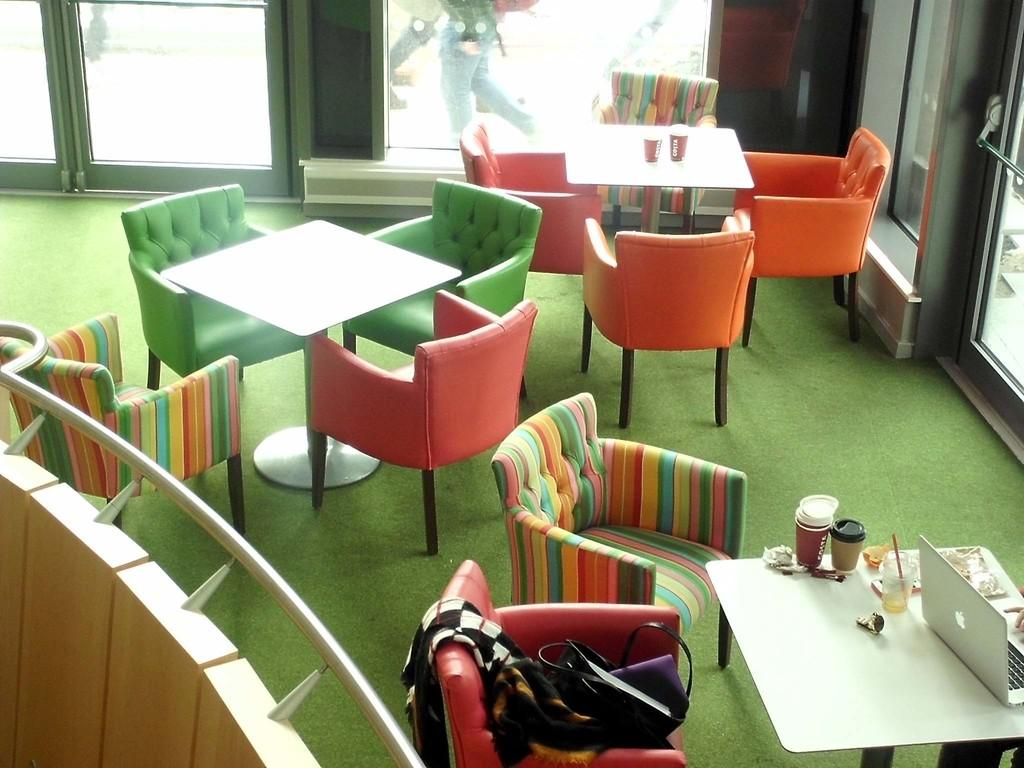What type of furniture is present in the room? There are chairs and tables in the room. What might be used for sitting or placing items in the room? Chairs and tables are present in the room for sitting and placing items. What can be seen in the background of the image? There is a door visible in the background, and people's legs are also visible. What might be used for entering or exiting the room? The door visible in the background might be used for entering or exiting the room. What type of cap can be seen on the table in the image? There is no cap present on the table in the image. What is the material of the copper knee visible in the image? There is no copper knee present in the image. 